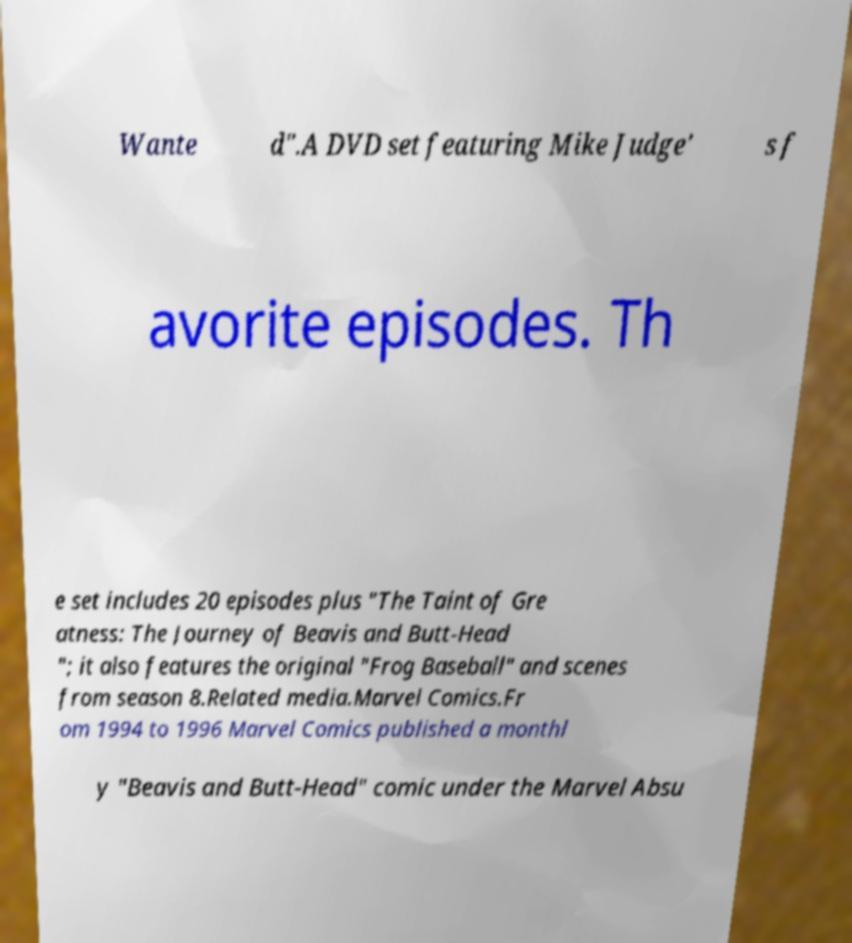Could you extract and type out the text from this image? Wante d".A DVD set featuring Mike Judge' s f avorite episodes. Th e set includes 20 episodes plus "The Taint of Gre atness: The Journey of Beavis and Butt-Head "; it also features the original "Frog Baseball" and scenes from season 8.Related media.Marvel Comics.Fr om 1994 to 1996 Marvel Comics published a monthl y "Beavis and Butt-Head" comic under the Marvel Absu 